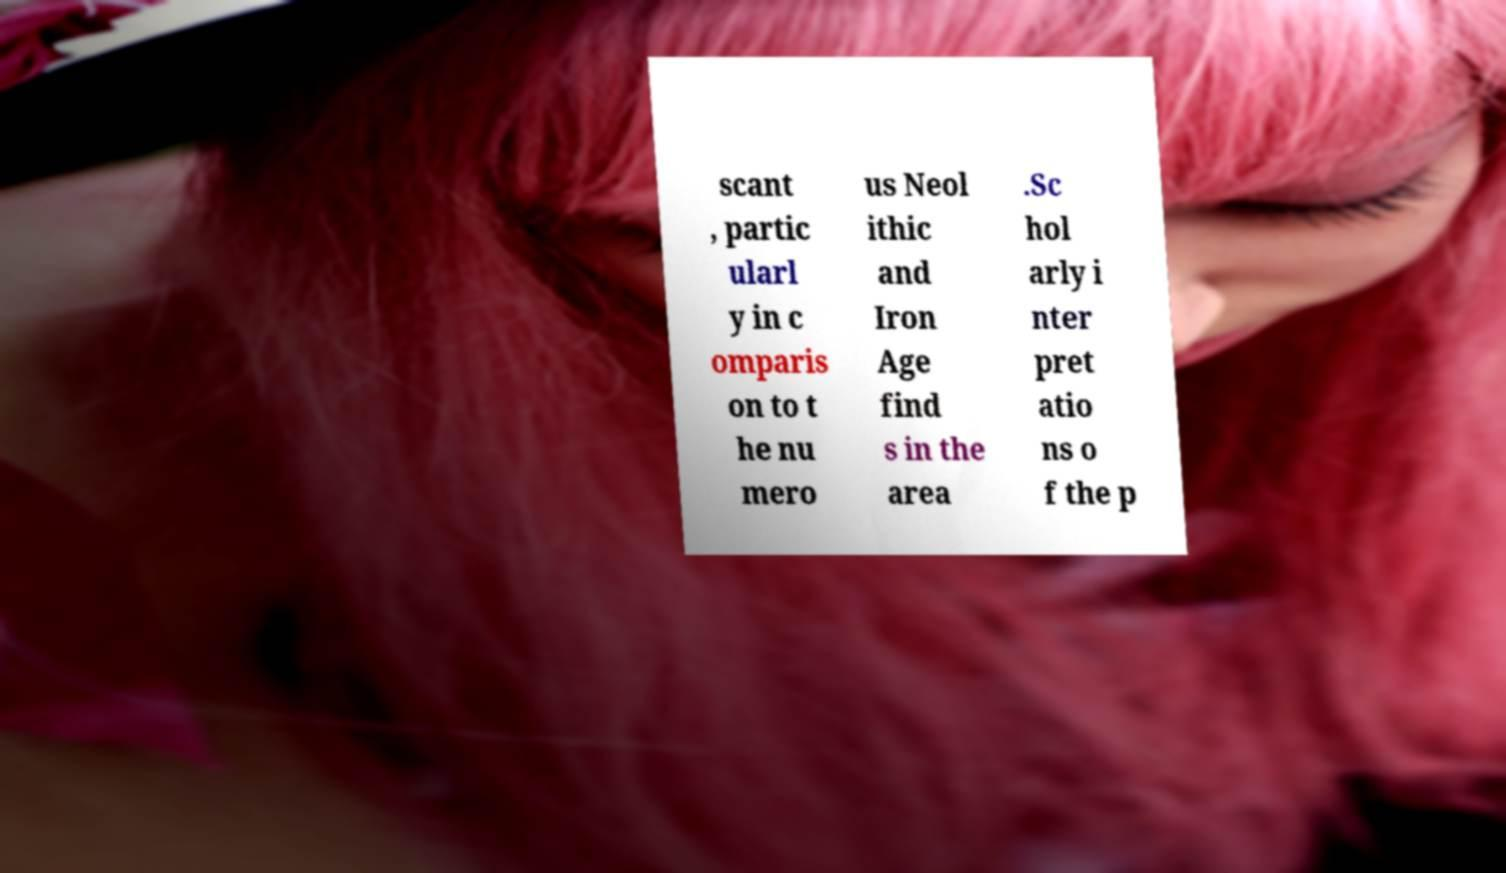Please read and relay the text visible in this image. What does it say? scant , partic ularl y in c omparis on to t he nu mero us Neol ithic and Iron Age find s in the area .Sc hol arly i nter pret atio ns o f the p 